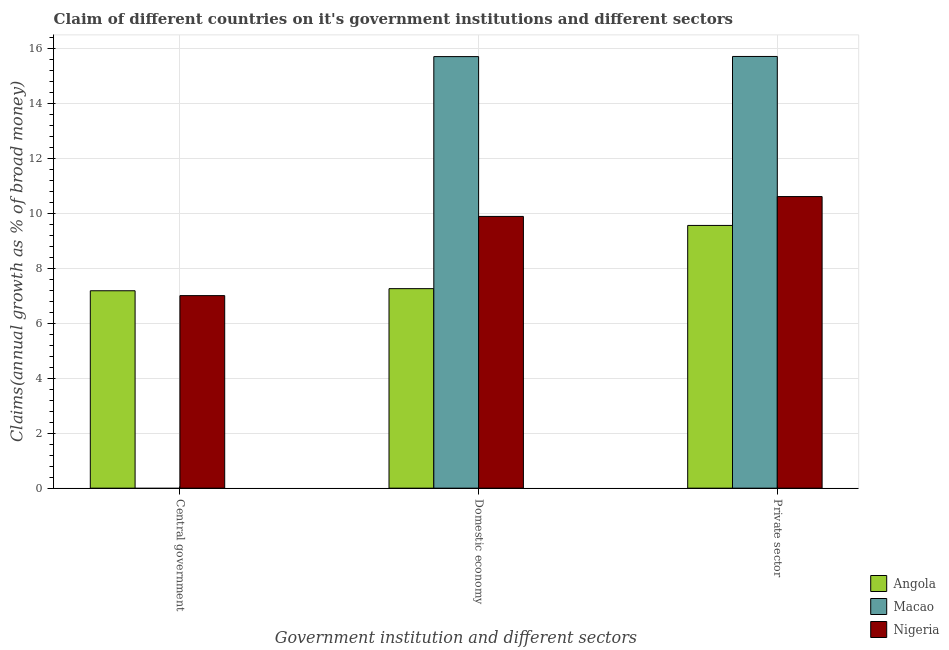Are the number of bars on each tick of the X-axis equal?
Give a very brief answer. No. How many bars are there on the 1st tick from the right?
Provide a short and direct response. 3. What is the label of the 2nd group of bars from the left?
Provide a short and direct response. Domestic economy. What is the percentage of claim on the domestic economy in Macao?
Offer a terse response. 15.7. Across all countries, what is the maximum percentage of claim on the central government?
Your answer should be compact. 7.18. Across all countries, what is the minimum percentage of claim on the domestic economy?
Make the answer very short. 7.26. In which country was the percentage of claim on the private sector maximum?
Offer a terse response. Macao. What is the total percentage of claim on the domestic economy in the graph?
Offer a very short reply. 32.85. What is the difference between the percentage of claim on the central government in Nigeria and that in Angola?
Provide a succinct answer. -0.18. What is the difference between the percentage of claim on the central government in Macao and the percentage of claim on the private sector in Angola?
Offer a terse response. -9.56. What is the average percentage of claim on the domestic economy per country?
Make the answer very short. 10.95. What is the difference between the percentage of claim on the domestic economy and percentage of claim on the private sector in Angola?
Your response must be concise. -2.3. In how many countries, is the percentage of claim on the central government greater than 0.4 %?
Ensure brevity in your answer.  2. What is the ratio of the percentage of claim on the domestic economy in Angola to that in Macao?
Provide a short and direct response. 0.46. Is the percentage of claim on the central government in Angola less than that in Nigeria?
Your answer should be compact. No. Is the difference between the percentage of claim on the central government in Angola and Nigeria greater than the difference between the percentage of claim on the private sector in Angola and Nigeria?
Provide a short and direct response. Yes. What is the difference between the highest and the second highest percentage of claim on the private sector?
Make the answer very short. 5.1. What is the difference between the highest and the lowest percentage of claim on the domestic economy?
Provide a short and direct response. 8.44. In how many countries, is the percentage of claim on the central government greater than the average percentage of claim on the central government taken over all countries?
Offer a very short reply. 2. Is the sum of the percentage of claim on the domestic economy in Macao and Angola greater than the maximum percentage of claim on the private sector across all countries?
Provide a short and direct response. Yes. Are all the bars in the graph horizontal?
Your response must be concise. No. What is the difference between two consecutive major ticks on the Y-axis?
Offer a very short reply. 2. Does the graph contain any zero values?
Make the answer very short. Yes. Where does the legend appear in the graph?
Make the answer very short. Bottom right. How are the legend labels stacked?
Your answer should be compact. Vertical. What is the title of the graph?
Offer a terse response. Claim of different countries on it's government institutions and different sectors. What is the label or title of the X-axis?
Provide a succinct answer. Government institution and different sectors. What is the label or title of the Y-axis?
Give a very brief answer. Claims(annual growth as % of broad money). What is the Claims(annual growth as % of broad money) of Angola in Central government?
Offer a very short reply. 7.18. What is the Claims(annual growth as % of broad money) in Nigeria in Central government?
Give a very brief answer. 7.01. What is the Claims(annual growth as % of broad money) of Angola in Domestic economy?
Provide a succinct answer. 7.26. What is the Claims(annual growth as % of broad money) in Macao in Domestic economy?
Make the answer very short. 15.7. What is the Claims(annual growth as % of broad money) in Nigeria in Domestic economy?
Provide a succinct answer. 9.89. What is the Claims(annual growth as % of broad money) of Angola in Private sector?
Provide a short and direct response. 9.56. What is the Claims(annual growth as % of broad money) of Macao in Private sector?
Offer a very short reply. 15.71. What is the Claims(annual growth as % of broad money) in Nigeria in Private sector?
Give a very brief answer. 10.61. Across all Government institution and different sectors, what is the maximum Claims(annual growth as % of broad money) of Angola?
Keep it short and to the point. 9.56. Across all Government institution and different sectors, what is the maximum Claims(annual growth as % of broad money) in Macao?
Provide a short and direct response. 15.71. Across all Government institution and different sectors, what is the maximum Claims(annual growth as % of broad money) of Nigeria?
Ensure brevity in your answer.  10.61. Across all Government institution and different sectors, what is the minimum Claims(annual growth as % of broad money) in Angola?
Make the answer very short. 7.18. Across all Government institution and different sectors, what is the minimum Claims(annual growth as % of broad money) in Nigeria?
Provide a short and direct response. 7.01. What is the total Claims(annual growth as % of broad money) of Angola in the graph?
Offer a very short reply. 24. What is the total Claims(annual growth as % of broad money) of Macao in the graph?
Provide a succinct answer. 31.41. What is the total Claims(annual growth as % of broad money) in Nigeria in the graph?
Your answer should be compact. 27.5. What is the difference between the Claims(annual growth as % of broad money) in Angola in Central government and that in Domestic economy?
Your response must be concise. -0.08. What is the difference between the Claims(annual growth as % of broad money) of Nigeria in Central government and that in Domestic economy?
Make the answer very short. -2.88. What is the difference between the Claims(annual growth as % of broad money) in Angola in Central government and that in Private sector?
Offer a very short reply. -2.38. What is the difference between the Claims(annual growth as % of broad money) in Nigeria in Central government and that in Private sector?
Keep it short and to the point. -3.6. What is the difference between the Claims(annual growth as % of broad money) of Angola in Domestic economy and that in Private sector?
Your answer should be very brief. -2.3. What is the difference between the Claims(annual growth as % of broad money) in Macao in Domestic economy and that in Private sector?
Offer a terse response. -0.01. What is the difference between the Claims(annual growth as % of broad money) of Nigeria in Domestic economy and that in Private sector?
Give a very brief answer. -0.72. What is the difference between the Claims(annual growth as % of broad money) in Angola in Central government and the Claims(annual growth as % of broad money) in Macao in Domestic economy?
Your answer should be compact. -8.52. What is the difference between the Claims(annual growth as % of broad money) of Angola in Central government and the Claims(annual growth as % of broad money) of Nigeria in Domestic economy?
Your answer should be very brief. -2.7. What is the difference between the Claims(annual growth as % of broad money) of Angola in Central government and the Claims(annual growth as % of broad money) of Macao in Private sector?
Your answer should be compact. -8.52. What is the difference between the Claims(annual growth as % of broad money) in Angola in Central government and the Claims(annual growth as % of broad money) in Nigeria in Private sector?
Offer a terse response. -3.43. What is the difference between the Claims(annual growth as % of broad money) in Angola in Domestic economy and the Claims(annual growth as % of broad money) in Macao in Private sector?
Offer a very short reply. -8.45. What is the difference between the Claims(annual growth as % of broad money) of Angola in Domestic economy and the Claims(annual growth as % of broad money) of Nigeria in Private sector?
Give a very brief answer. -3.35. What is the difference between the Claims(annual growth as % of broad money) in Macao in Domestic economy and the Claims(annual growth as % of broad money) in Nigeria in Private sector?
Your response must be concise. 5.09. What is the average Claims(annual growth as % of broad money) in Angola per Government institution and different sectors?
Make the answer very short. 8. What is the average Claims(annual growth as % of broad money) of Macao per Government institution and different sectors?
Provide a succinct answer. 10.47. What is the average Claims(annual growth as % of broad money) in Nigeria per Government institution and different sectors?
Make the answer very short. 9.17. What is the difference between the Claims(annual growth as % of broad money) in Angola and Claims(annual growth as % of broad money) in Nigeria in Central government?
Offer a very short reply. 0.18. What is the difference between the Claims(annual growth as % of broad money) in Angola and Claims(annual growth as % of broad money) in Macao in Domestic economy?
Offer a very short reply. -8.44. What is the difference between the Claims(annual growth as % of broad money) in Angola and Claims(annual growth as % of broad money) in Nigeria in Domestic economy?
Offer a terse response. -2.63. What is the difference between the Claims(annual growth as % of broad money) in Macao and Claims(annual growth as % of broad money) in Nigeria in Domestic economy?
Ensure brevity in your answer.  5.82. What is the difference between the Claims(annual growth as % of broad money) of Angola and Claims(annual growth as % of broad money) of Macao in Private sector?
Offer a terse response. -6.15. What is the difference between the Claims(annual growth as % of broad money) in Angola and Claims(annual growth as % of broad money) in Nigeria in Private sector?
Your answer should be compact. -1.05. What is the difference between the Claims(annual growth as % of broad money) of Macao and Claims(annual growth as % of broad money) of Nigeria in Private sector?
Provide a succinct answer. 5.1. What is the ratio of the Claims(annual growth as % of broad money) of Angola in Central government to that in Domestic economy?
Ensure brevity in your answer.  0.99. What is the ratio of the Claims(annual growth as % of broad money) in Nigeria in Central government to that in Domestic economy?
Your answer should be very brief. 0.71. What is the ratio of the Claims(annual growth as % of broad money) of Angola in Central government to that in Private sector?
Keep it short and to the point. 0.75. What is the ratio of the Claims(annual growth as % of broad money) of Nigeria in Central government to that in Private sector?
Make the answer very short. 0.66. What is the ratio of the Claims(annual growth as % of broad money) in Angola in Domestic economy to that in Private sector?
Ensure brevity in your answer.  0.76. What is the ratio of the Claims(annual growth as % of broad money) of Nigeria in Domestic economy to that in Private sector?
Provide a short and direct response. 0.93. What is the difference between the highest and the second highest Claims(annual growth as % of broad money) in Angola?
Offer a very short reply. 2.3. What is the difference between the highest and the second highest Claims(annual growth as % of broad money) in Nigeria?
Your response must be concise. 0.72. What is the difference between the highest and the lowest Claims(annual growth as % of broad money) in Angola?
Offer a very short reply. 2.38. What is the difference between the highest and the lowest Claims(annual growth as % of broad money) in Macao?
Your answer should be compact. 15.71. What is the difference between the highest and the lowest Claims(annual growth as % of broad money) of Nigeria?
Ensure brevity in your answer.  3.6. 